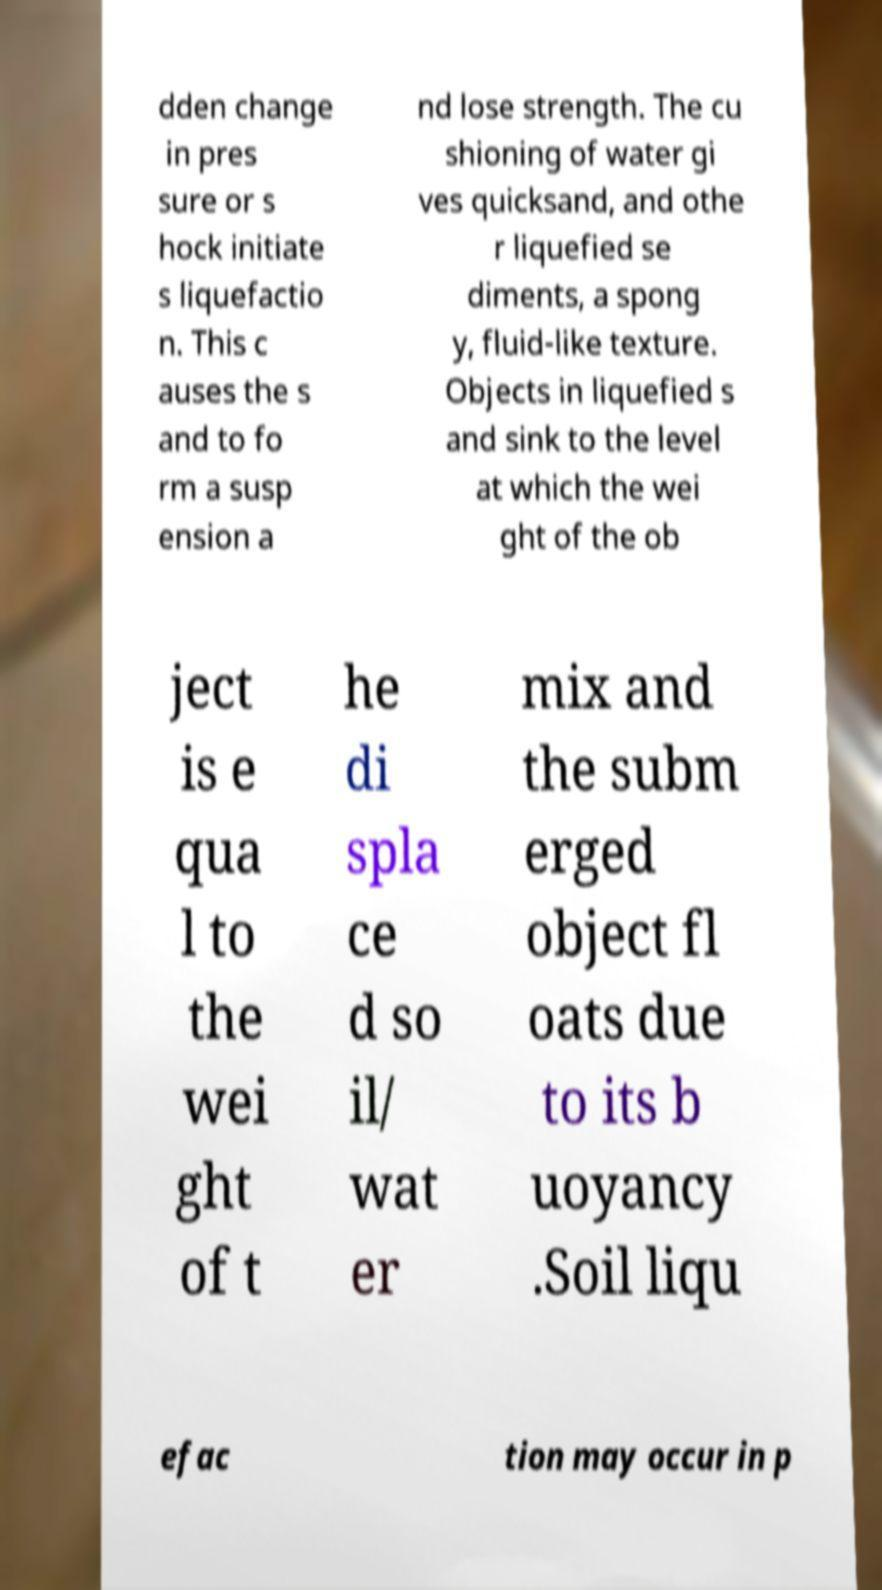Please read and relay the text visible in this image. What does it say? dden change in pres sure or s hock initiate s liquefactio n. This c auses the s and to fo rm a susp ension a nd lose strength. The cu shioning of water gi ves quicksand, and othe r liquefied se diments, a spong y, fluid-like texture. Objects in liquefied s and sink to the level at which the wei ght of the ob ject is e qua l to the wei ght of t he di spla ce d so il/ wat er mix and the subm erged object fl oats due to its b uoyancy .Soil liqu efac tion may occur in p 